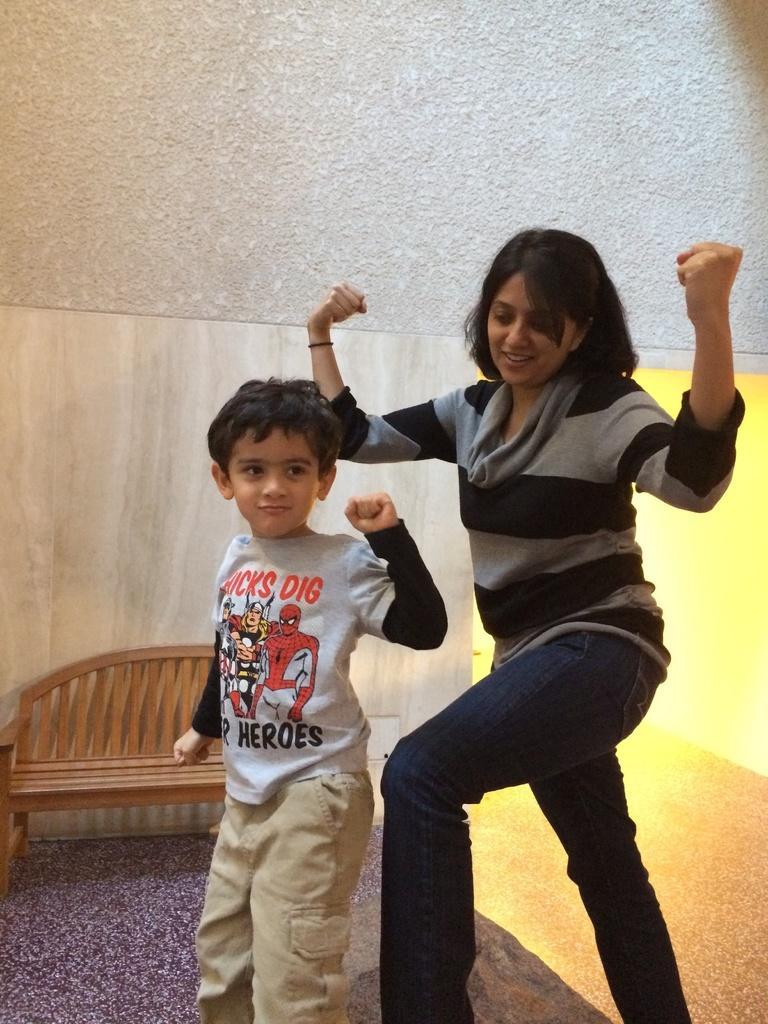Describe this image in one or two sentences. In this image we can see we can see a lady and child standing. In the background we can see a chair. 